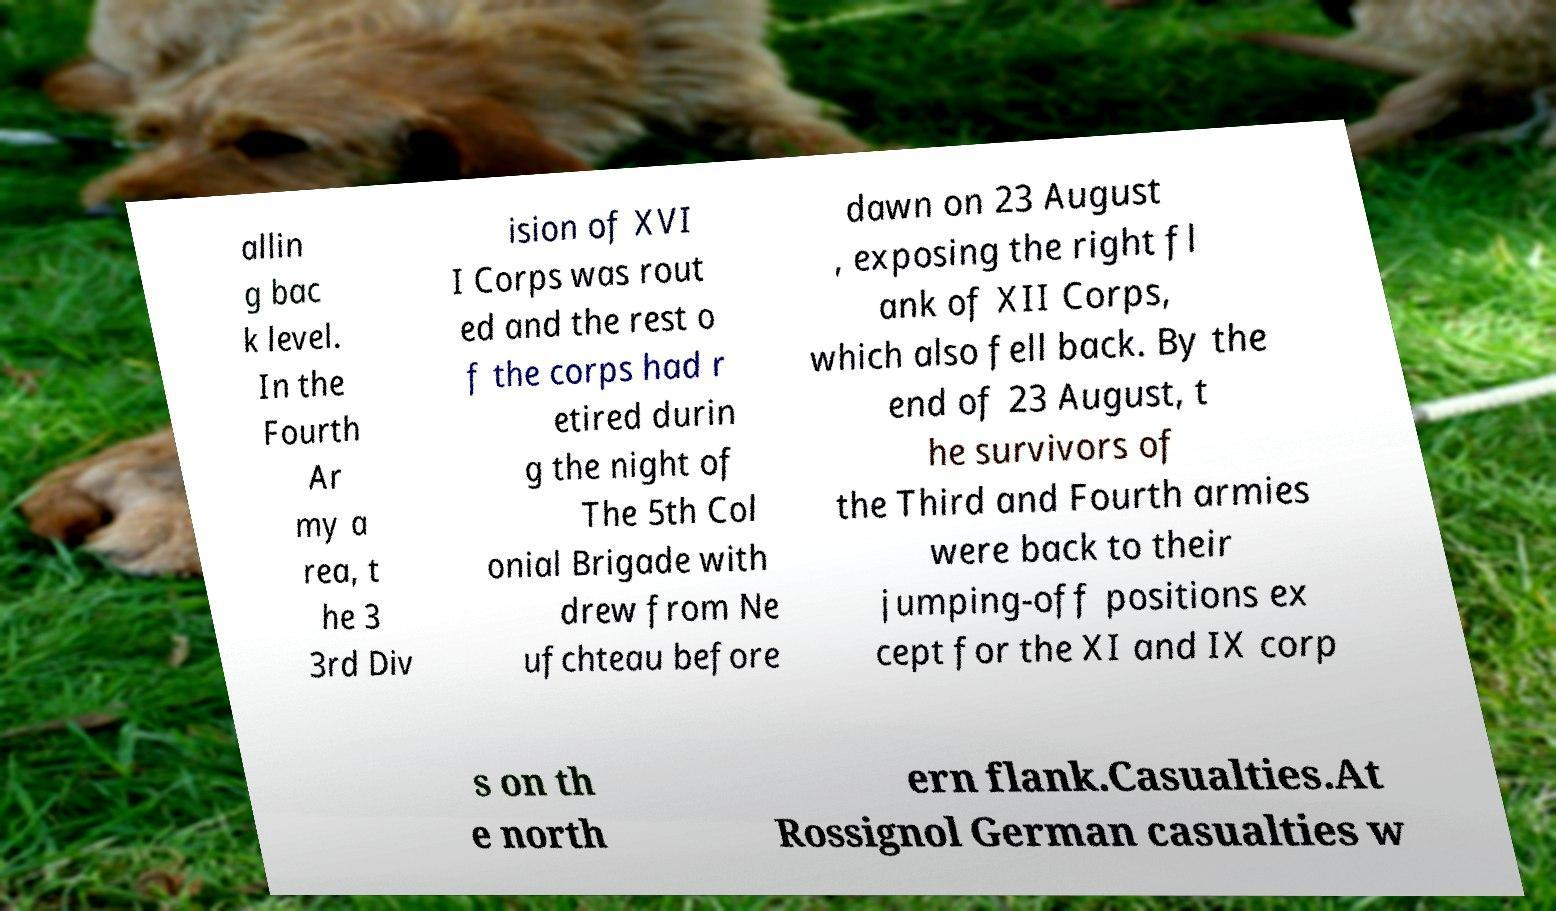For documentation purposes, I need the text within this image transcribed. Could you provide that? allin g bac k level. In the Fourth Ar my a rea, t he 3 3rd Div ision of XVI I Corps was rout ed and the rest o f the corps had r etired durin g the night of The 5th Col onial Brigade with drew from Ne ufchteau before dawn on 23 August , exposing the right fl ank of XII Corps, which also fell back. By the end of 23 August, t he survivors of the Third and Fourth armies were back to their jumping-off positions ex cept for the XI and IX corp s on th e north ern flank.Casualties.At Rossignol German casualties w 